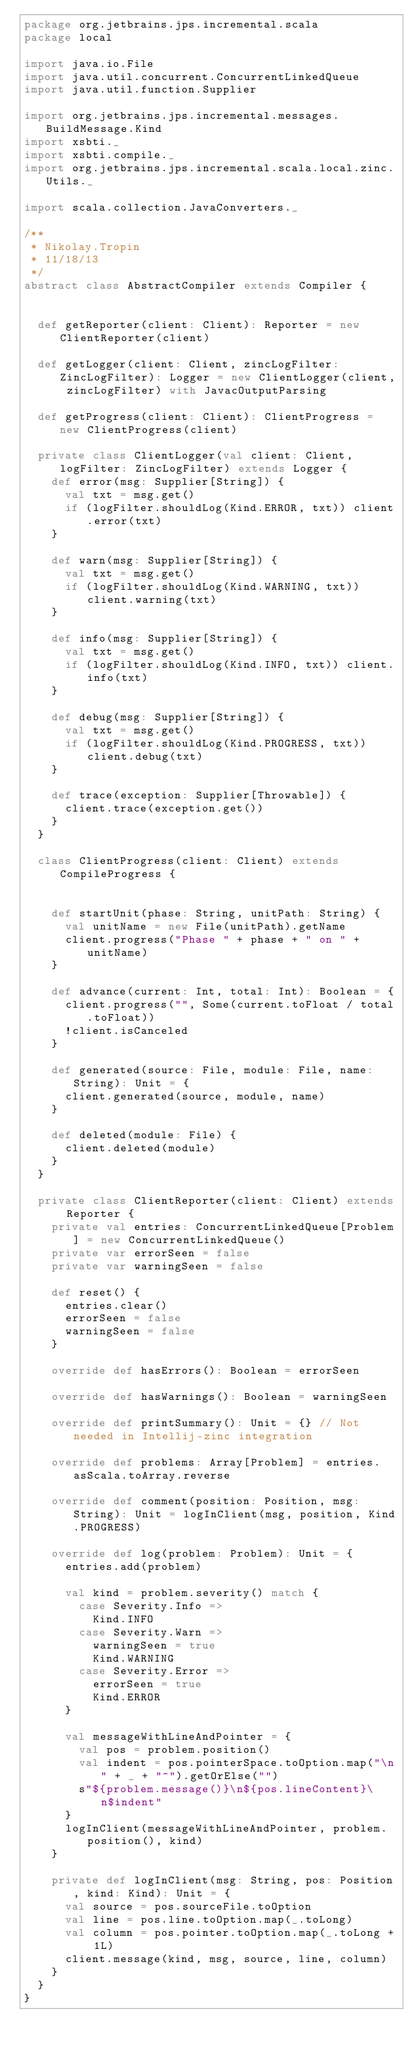<code> <loc_0><loc_0><loc_500><loc_500><_Scala_>package org.jetbrains.jps.incremental.scala
package local

import java.io.File
import java.util.concurrent.ConcurrentLinkedQueue
import java.util.function.Supplier

import org.jetbrains.jps.incremental.messages.BuildMessage.Kind
import xsbti._
import xsbti.compile._
import org.jetbrains.jps.incremental.scala.local.zinc.Utils._

import scala.collection.JavaConverters._

/**
 * Nikolay.Tropin
 * 11/18/13
 */
abstract class AbstractCompiler extends Compiler {


  def getReporter(client: Client): Reporter = new ClientReporter(client)

  def getLogger(client: Client, zincLogFilter: ZincLogFilter): Logger = new ClientLogger(client, zincLogFilter) with JavacOutputParsing

  def getProgress(client: Client): ClientProgress = new ClientProgress(client)

  private class ClientLogger(val client: Client, logFilter: ZincLogFilter) extends Logger {
    def error(msg: Supplier[String]) {
      val txt = msg.get()
      if (logFilter.shouldLog(Kind.ERROR, txt)) client.error(txt)
    }

    def warn(msg: Supplier[String]) {
      val txt = msg.get()
      if (logFilter.shouldLog(Kind.WARNING, txt)) client.warning(txt)
    }

    def info(msg: Supplier[String]) {
      val txt = msg.get()
      if (logFilter.shouldLog(Kind.INFO, txt)) client.info(txt)
    }

    def debug(msg: Supplier[String]) {
      val txt = msg.get()
      if (logFilter.shouldLog(Kind.PROGRESS, txt)) client.debug(txt)
    }

    def trace(exception: Supplier[Throwable]) {
      client.trace(exception.get())
    }
  }

  class ClientProgress(client: Client) extends CompileProgress {


    def startUnit(phase: String, unitPath: String) {
      val unitName = new File(unitPath).getName
      client.progress("Phase " + phase + " on " + unitName)
    }

    def advance(current: Int, total: Int): Boolean = {
      client.progress("", Some(current.toFloat / total.toFloat))
      !client.isCanceled
    }

    def generated(source: File, module: File, name: String): Unit = {
      client.generated(source, module, name)
    }

    def deleted(module: File) {
      client.deleted(module)
    }
  }

  private class ClientReporter(client: Client) extends Reporter {
    private val entries: ConcurrentLinkedQueue[Problem] = new ConcurrentLinkedQueue()
    private var errorSeen = false
    private var warningSeen = false

    def reset() {
      entries.clear()
      errorSeen = false
      warningSeen = false
    }

    override def hasErrors(): Boolean = errorSeen

    override def hasWarnings(): Boolean = warningSeen

    override def printSummary(): Unit = {} // Not needed in Intellij-zinc integration

    override def problems: Array[Problem] = entries.asScala.toArray.reverse

    override def comment(position: Position, msg: String): Unit = logInClient(msg, position, Kind.PROGRESS)

    override def log(problem: Problem): Unit = {
      entries.add(problem)

      val kind = problem.severity() match {
        case Severity.Info =>
          Kind.INFO
        case Severity.Warn =>
          warningSeen = true
          Kind.WARNING
        case Severity.Error =>
          errorSeen = true
          Kind.ERROR
      }

      val messageWithLineAndPointer = {
        val pos = problem.position()
        val indent = pos.pointerSpace.toOption.map("\n" + _ + "^").getOrElse("")
        s"${problem.message()}\n${pos.lineContent}\n$indent"
      }
      logInClient(messageWithLineAndPointer, problem.position(), kind)
    }

    private def logInClient(msg: String, pos: Position, kind: Kind): Unit = {
      val source = pos.sourceFile.toOption
      val line = pos.line.toOption.map(_.toLong)
      val column = pos.pointer.toOption.map(_.toLong + 1L)
      client.message(kind, msg, source, line, column)
    }
  }
}

</code> 